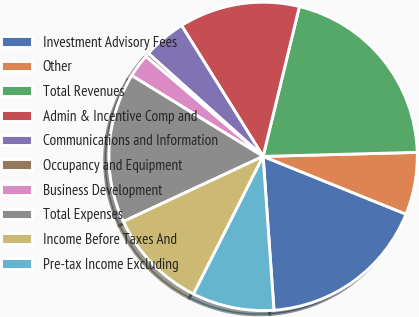Convert chart. <chart><loc_0><loc_0><loc_500><loc_500><pie_chart><fcel>Investment Advisory Fees<fcel>Other<fcel>Total Revenues<fcel>Admin & Incentive Comp and<fcel>Communications and Information<fcel>Occupancy and Equipment<fcel>Business Development<fcel>Total Expenses<fcel>Income Before Taxes And<fcel>Pre-tax Income Excluding<nl><fcel>17.76%<fcel>6.53%<fcel>20.8%<fcel>12.65%<fcel>4.49%<fcel>0.41%<fcel>2.45%<fcel>15.72%<fcel>10.61%<fcel>8.57%<nl></chart> 